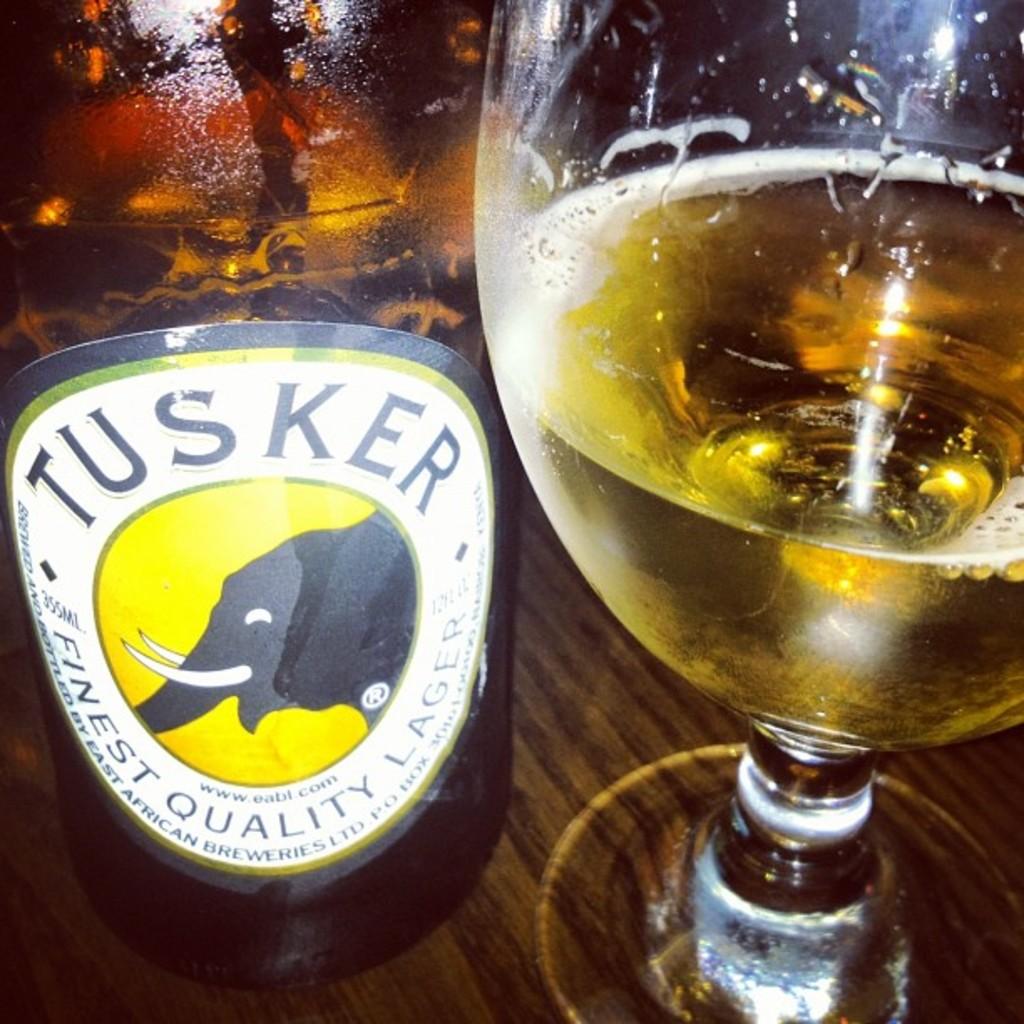What is the name of this beer?
Provide a short and direct response. Tusker. 